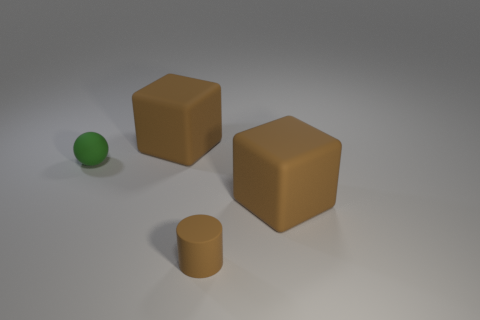What materials can you identify in the scene? The two cubes and the cylinder appear to be made of a matte material, possibly a type of plastic or painted wood. The small green sphere seems to have a shiny, rubber-like texture. 